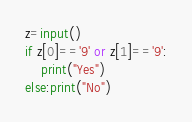<code> <loc_0><loc_0><loc_500><loc_500><_Python_>z=input()
if z[0]=='9' or z[1]=='9':
    print("Yes")
else:print("No")</code> 